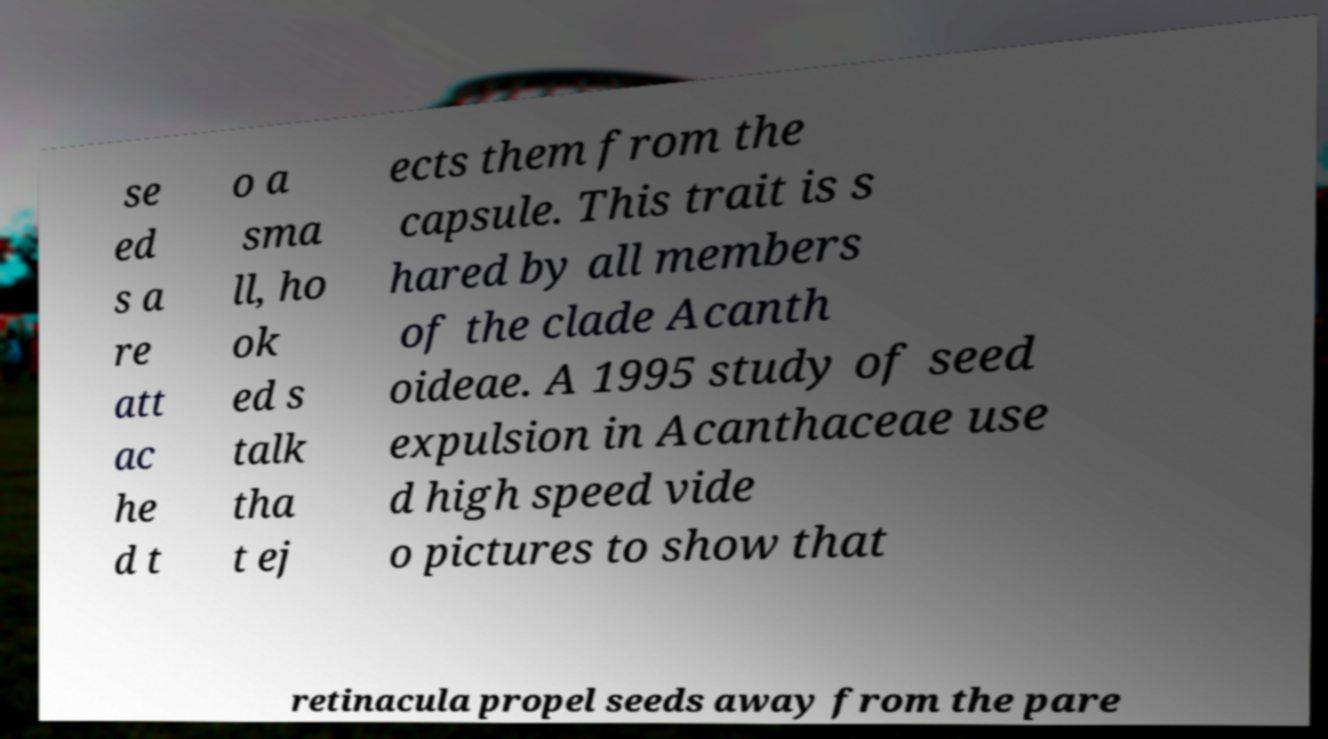Can you accurately transcribe the text from the provided image for me? se ed s a re att ac he d t o a sma ll, ho ok ed s talk tha t ej ects them from the capsule. This trait is s hared by all members of the clade Acanth oideae. A 1995 study of seed expulsion in Acanthaceae use d high speed vide o pictures to show that retinacula propel seeds away from the pare 